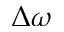Convert formula to latex. <formula><loc_0><loc_0><loc_500><loc_500>\Delta \omega</formula> 